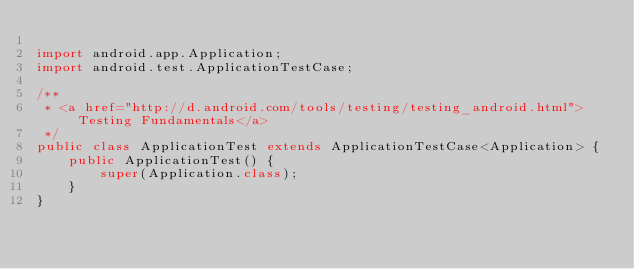<code> <loc_0><loc_0><loc_500><loc_500><_Java_>
import android.app.Application;
import android.test.ApplicationTestCase;

/**
 * <a href="http://d.android.com/tools/testing/testing_android.html">Testing Fundamentals</a>
 */
public class ApplicationTest extends ApplicationTestCase<Application> {
    public ApplicationTest() {
        super(Application.class);
    }
}</code> 